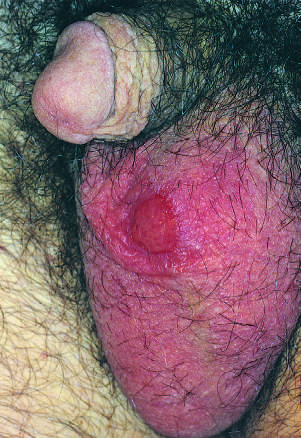what are painless despite the presence of ulceration?
Answer the question using a single word or phrase. Syphilitic chancre 